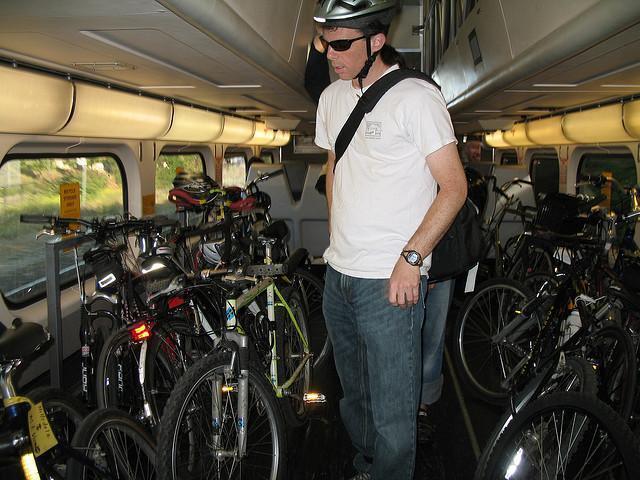How many bicycles can you see?
Give a very brief answer. 10. How many people are there?
Give a very brief answer. 1. 